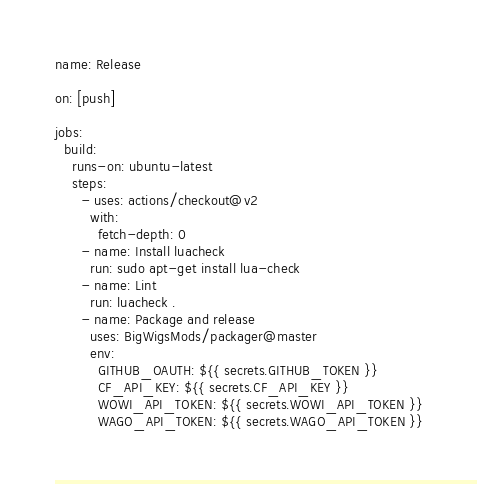Convert code to text. <code><loc_0><loc_0><loc_500><loc_500><_YAML_>name: Release

on: [push]

jobs:
  build:
    runs-on: ubuntu-latest
    steps:
      - uses: actions/checkout@v2
        with:
          fetch-depth: 0
      - name: Install luacheck
        run: sudo apt-get install lua-check
      - name: Lint
        run: luacheck .
      - name: Package and release
        uses: BigWigsMods/packager@master
        env:
          GITHUB_OAUTH: ${{ secrets.GITHUB_TOKEN }}
          CF_API_KEY: ${{ secrets.CF_API_KEY }}
          WOWI_API_TOKEN: ${{ secrets.WOWI_API_TOKEN }}
          WAGO_API_TOKEN: ${{ secrets.WAGO_API_TOKEN }}
</code> 